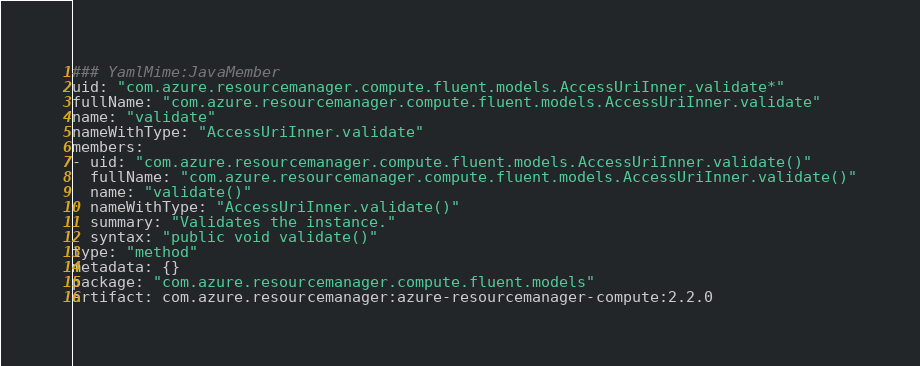<code> <loc_0><loc_0><loc_500><loc_500><_YAML_>### YamlMime:JavaMember
uid: "com.azure.resourcemanager.compute.fluent.models.AccessUriInner.validate*"
fullName: "com.azure.resourcemanager.compute.fluent.models.AccessUriInner.validate"
name: "validate"
nameWithType: "AccessUriInner.validate"
members:
- uid: "com.azure.resourcemanager.compute.fluent.models.AccessUriInner.validate()"
  fullName: "com.azure.resourcemanager.compute.fluent.models.AccessUriInner.validate()"
  name: "validate()"
  nameWithType: "AccessUriInner.validate()"
  summary: "Validates the instance."
  syntax: "public void validate()"
type: "method"
metadata: {}
package: "com.azure.resourcemanager.compute.fluent.models"
artifact: com.azure.resourcemanager:azure-resourcemanager-compute:2.2.0
</code> 